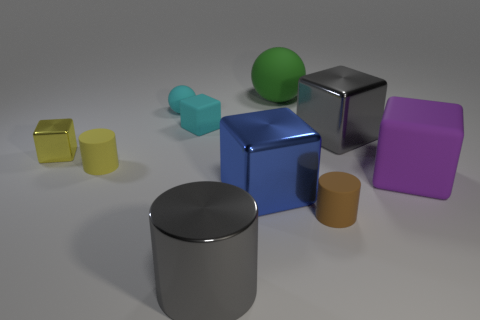Are there any reflections visible on the objects or the surface? Yes, reflections are quite prominent on a few objects. The gray shiny cylinder and the blue metallic cube reflect the environment and the light source, creating a sense of depth and realism in the image.  What does the lighting in the scene suggest about the environment? The soft shadows and subtle highlights indicate a diffused lighting environment, perhaps from an overhead light source. It gives the scene a calm and neutral appearance, which could represent an indoor setting with controlled lighting. 